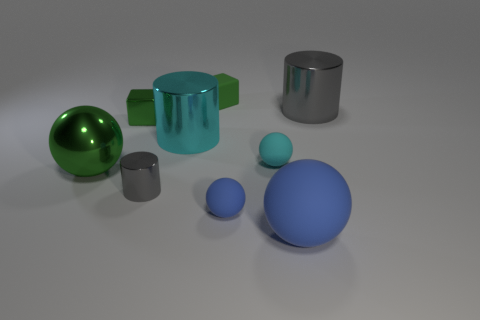Subtract 2 balls. How many balls are left? 2 Subtract all cyan balls. How many balls are left? 3 Subtract all purple spheres. Subtract all cyan cubes. How many spheres are left? 4 Add 1 tiny purple shiny cylinders. How many objects exist? 10 Subtract all cylinders. How many objects are left? 6 Add 8 cyan shiny things. How many cyan shiny things are left? 9 Add 9 large blue matte spheres. How many large blue matte spheres exist? 10 Subtract 0 brown cylinders. How many objects are left? 9 Subtract all large cyan shiny cubes. Subtract all large cylinders. How many objects are left? 7 